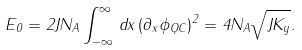<formula> <loc_0><loc_0><loc_500><loc_500>E _ { 0 } = 2 J N _ { A } \int _ { - \infty } ^ { \infty } \, d x \, ( \partial _ { x } \phi _ { Q C } ) ^ { 2 } = 4 N _ { A } \sqrt { J K _ { y } } .</formula> 